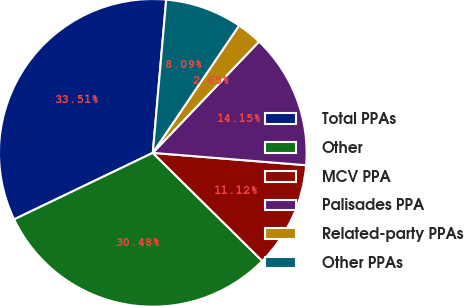Convert chart to OTSL. <chart><loc_0><loc_0><loc_500><loc_500><pie_chart><fcel>Total PPAs<fcel>Other<fcel>MCV PPA<fcel>Palisades PPA<fcel>Related-party PPAs<fcel>Other PPAs<nl><fcel>33.51%<fcel>30.48%<fcel>11.12%<fcel>14.15%<fcel>2.65%<fcel>8.09%<nl></chart> 